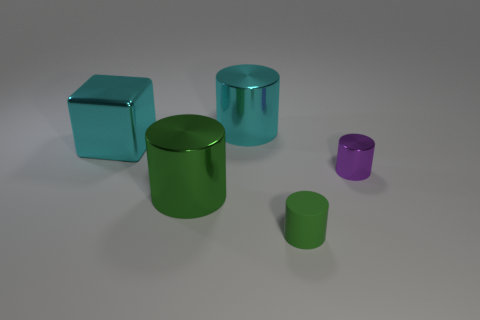Subtract all green blocks. How many green cylinders are left? 2 Subtract all metal cylinders. How many cylinders are left? 1 Subtract 2 cylinders. How many cylinders are left? 2 Add 4 large cubes. How many objects exist? 9 Subtract all brown cylinders. Subtract all yellow cubes. How many cylinders are left? 4 Subtract all blocks. How many objects are left? 4 Add 3 big purple shiny things. How many big purple shiny things exist? 3 Subtract 0 yellow blocks. How many objects are left? 5 Subtract all big purple cubes. Subtract all cyan metallic cylinders. How many objects are left? 4 Add 2 large green shiny objects. How many large green shiny objects are left? 3 